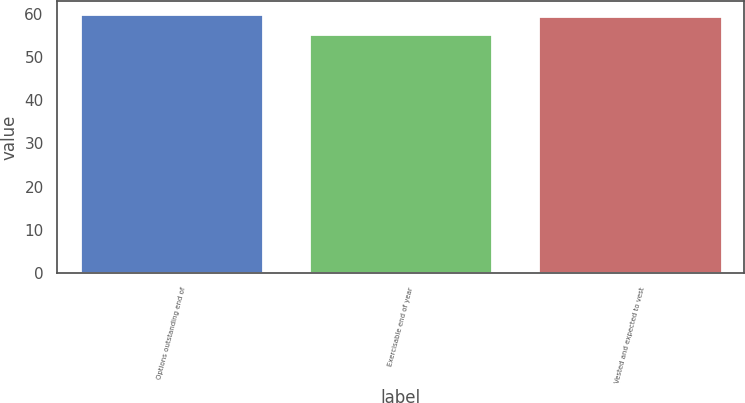<chart> <loc_0><loc_0><loc_500><loc_500><bar_chart><fcel>Options outstanding end of<fcel>Exercisable end of year<fcel>Vested and expected to vest<nl><fcel>59.86<fcel>55.37<fcel>59.43<nl></chart> 